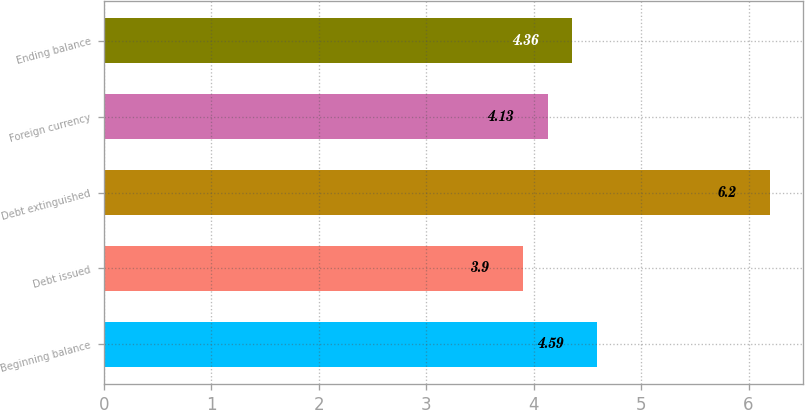Convert chart to OTSL. <chart><loc_0><loc_0><loc_500><loc_500><bar_chart><fcel>Beginning balance<fcel>Debt issued<fcel>Debt extinguished<fcel>Foreign currency<fcel>Ending balance<nl><fcel>4.59<fcel>3.9<fcel>6.2<fcel>4.13<fcel>4.36<nl></chart> 